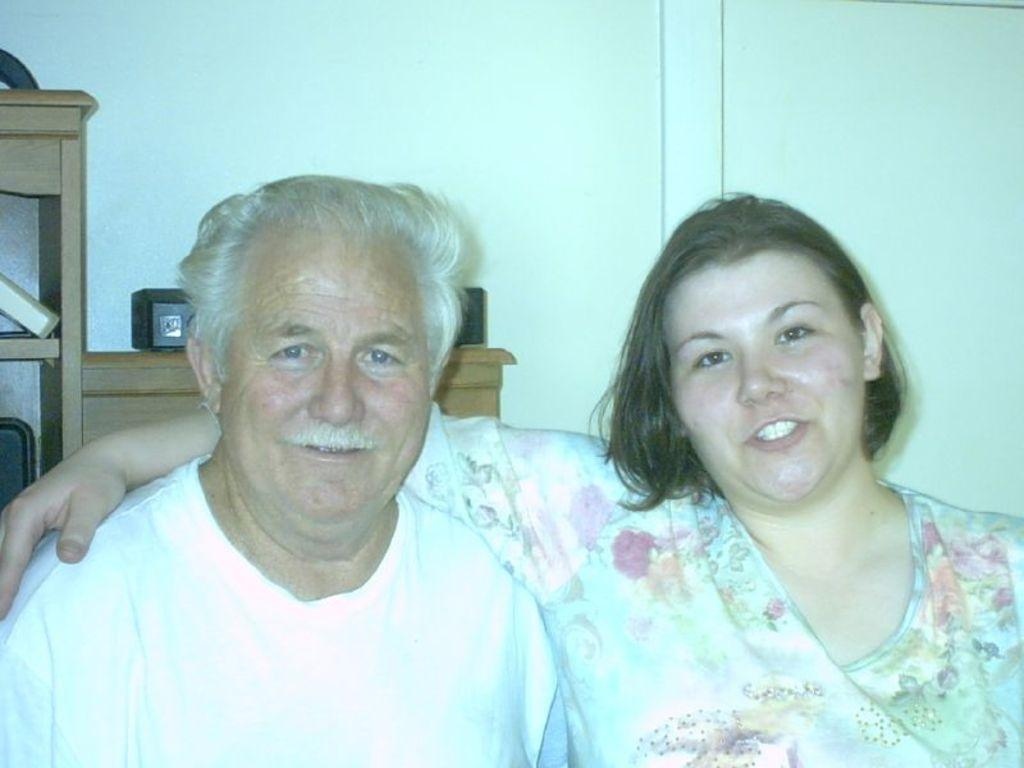How many people are in the image? There are two persons in the image. What expressions do the people have? Both persons have smiling faces. What can be seen in the background of the image? There is a wall and a wooden object in the background of the image. What type of drug is the creature using in the image? There is no creature or drug present in the image. What answer is the person giving in the image? The image does not show the persons giving any answers, so it cannot be determined from the picture. 